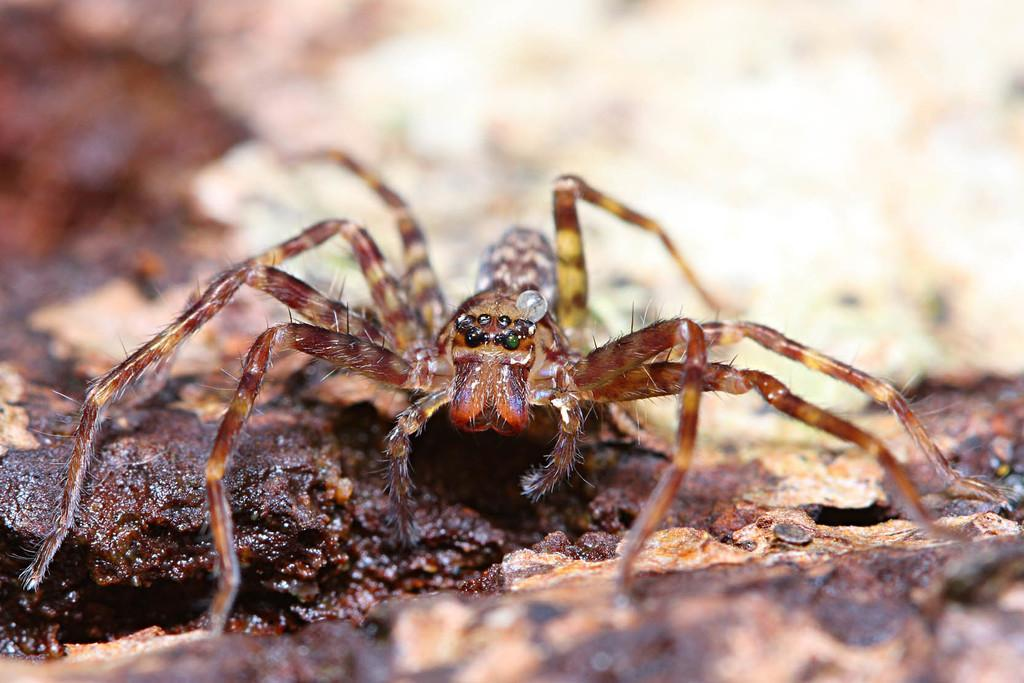What is present on the ground in the image? There is a spider in the image. Can you describe the spider's appearance? The spider is brown in color. Where is the tree located in the image? There is no tree present in the image; it only features a spider on the ground. What type of finger can be seen in the image? There are no fingers present in the image; it only features a spider on the ground. 